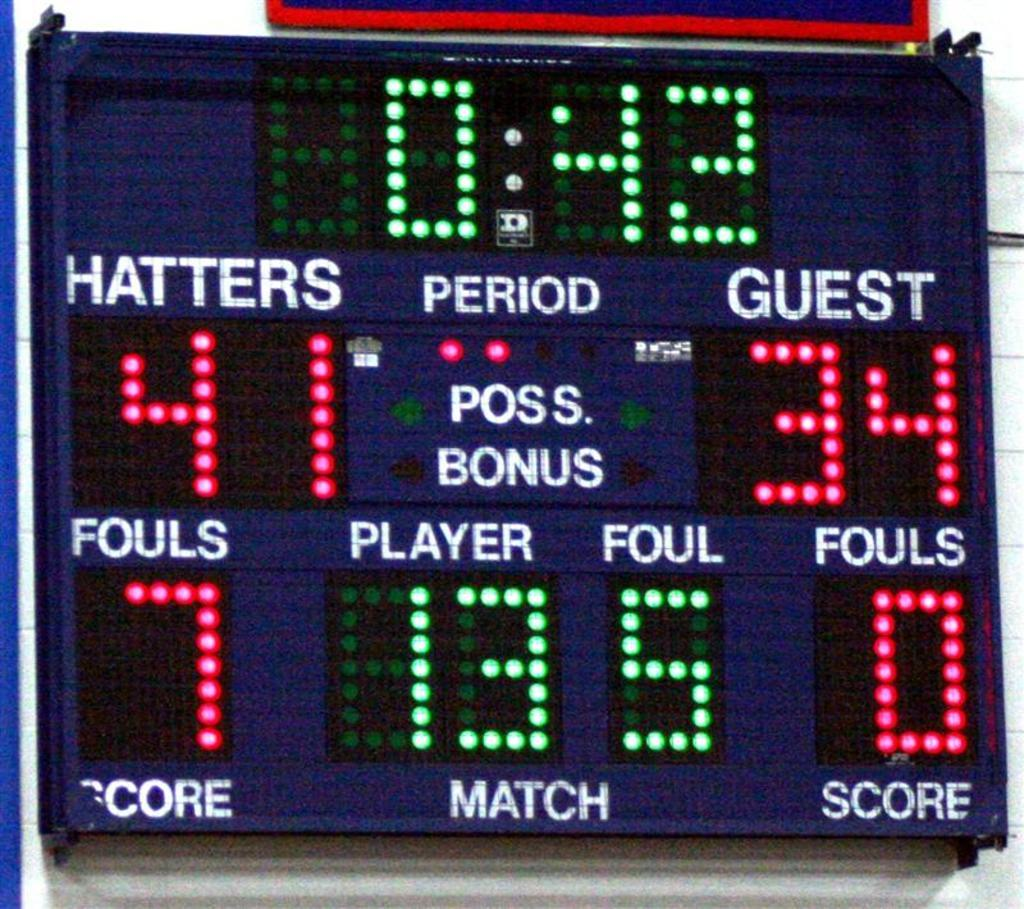<image>
Relay a brief, clear account of the picture shown. A scoreboard shows that the Hatters are winning, with a score of 41 to 34. 